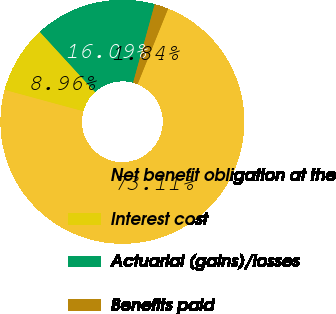Convert chart to OTSL. <chart><loc_0><loc_0><loc_500><loc_500><pie_chart><fcel>Net benefit obligation at the<fcel>Interest cost<fcel>Actuarial (gains)/losses<fcel>Benefits paid<nl><fcel>73.11%<fcel>8.96%<fcel>16.09%<fcel>1.84%<nl></chart> 